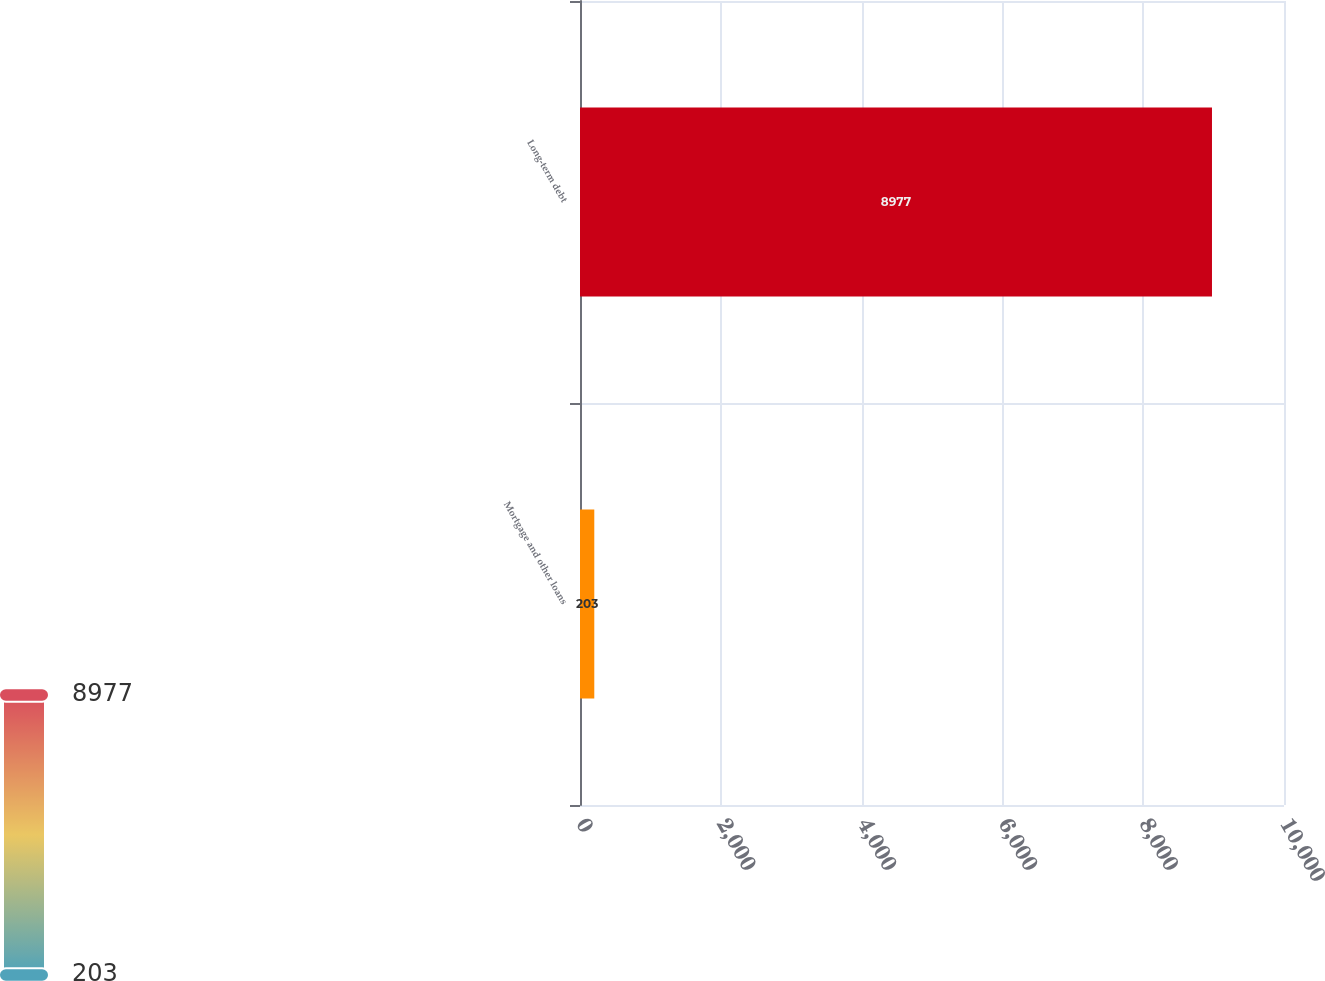Convert chart. <chart><loc_0><loc_0><loc_500><loc_500><bar_chart><fcel>Mortgage and other loans<fcel>Long-term debt<nl><fcel>203<fcel>8977<nl></chart> 